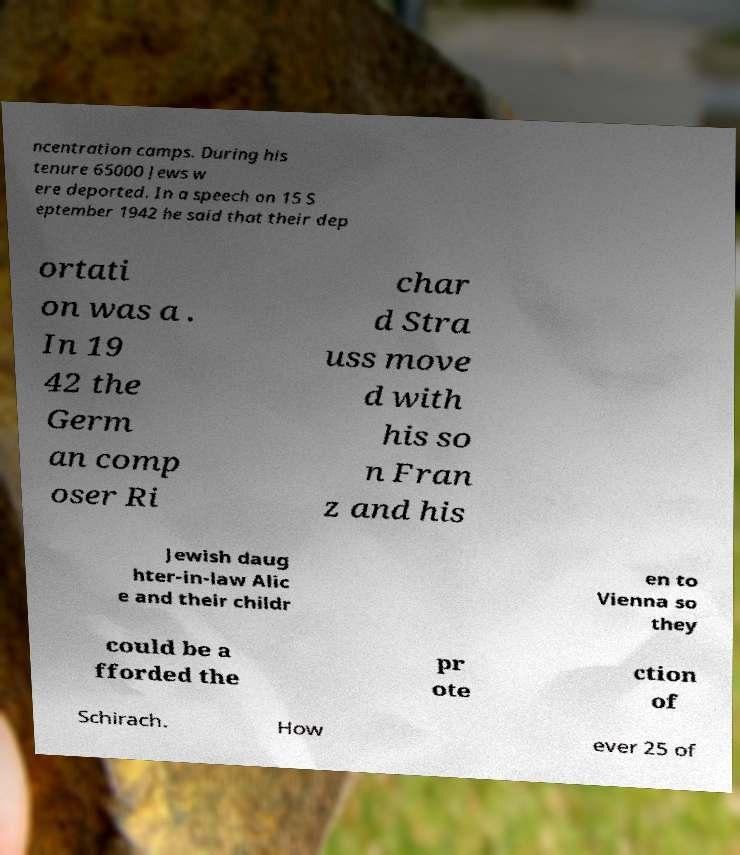Could you extract and type out the text from this image? ncentration camps. During his tenure 65000 Jews w ere deported. In a speech on 15 S eptember 1942 he said that their dep ortati on was a . In 19 42 the Germ an comp oser Ri char d Stra uss move d with his so n Fran z and his Jewish daug hter-in-law Alic e and their childr en to Vienna so they could be a fforded the pr ote ction of Schirach. How ever 25 of 